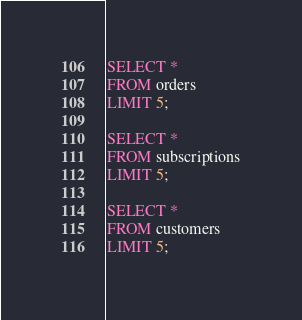Convert code to text. <code><loc_0><loc_0><loc_500><loc_500><_SQL_>
SELECT *
FROM orders
LIMIT 5;

SELECT *
FROM subscriptions
LIMIT 5;

SELECT * 
FROM customers
LIMIT 5;</code> 